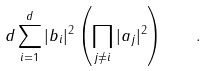<formula> <loc_0><loc_0><loc_500><loc_500>d \sum _ { i = 1 } ^ { d } | b _ { i } | ^ { 2 } \left ( \prod _ { j \neq i } | a _ { j } | ^ { 2 } \right ) \quad .</formula> 